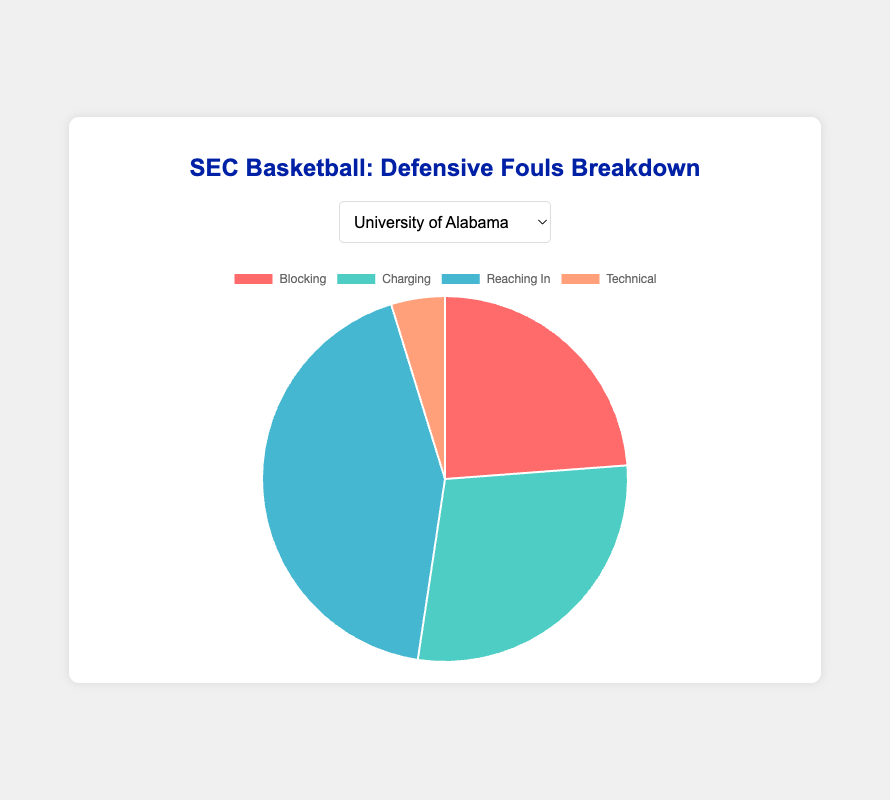Which team has the highest percentage of Reaching In fouls? To determine the team with the highest percentage of Reaching In fouls, we need to calculate the percentage of Reaching In fouls for each team by dividing the number of Reaching In fouls by the total number of fouls for that team and comparing the results. The team with the highest resulting percentage is the answer.
Answer: University of Alabama Which team has the lowest number of Technical fouls? Look at the Technical fouls segment of each pie chart represented by the specific team and identify the smallest value.
Answer: University of Kentucky What is the total number of Blocking fouls across all five teams? Sum the Blocking fouls from each team: 25 (Alabama) + 28 (Florida) + 32 (Kentucky) + 27 (Tennessee) + 30 (Auburn).
Answer: 142 For the University of Florida, how many more Reaching In fouls are there compared to Technical fouls? Subtract the number of Technical fouls from the number of Reaching In fouls for Florida: 40 (Reaching In) - 7 (Technical).
Answer: 33 Which type of foul has the least total occurrences across all teams combined? Sum each type of foul across all teams and compare the totals. The foul with the smallest sum is the answer. For instance, add up all Blocking, Charging, Reaching In, and Technical fouls separately for each team and then compare.
Answer: Technical Which two teams have the closest number of Charging fouls? Compare the Charging fouls numbers for each team and identify the two teams whose Charging fouls differ the least.
Answer: University of Tennessee and University of Kentucky On average, how many Blocking fouls does each team commit? Sum the Blocking fouls for all five teams and then divide by the number of teams: (25 + 28 + 32 + 27 + 30) / 5.
Answer: 28.4 Which team's pie chart would have the smallest slice for Technical fouls? Compare the Technical fouls slice of the pie chart for each team and identify the smallest value.
Answer: University of Kentucky If the total number of fouls committed by the University of Tennessee is 100, what percentage of these are Charging fouls? Divide the number of Charging fouls committed by the University of Tennessee by the total number of fouls committed by them: 25 / 100 * 100%.
Answer: 25% For Auburn University, which type of foul does it commit the most frequently? Observe Auburn University’s pie chart and identify the largest slice which indicates the most frequently committed foul type.
Answer: Reaching In 